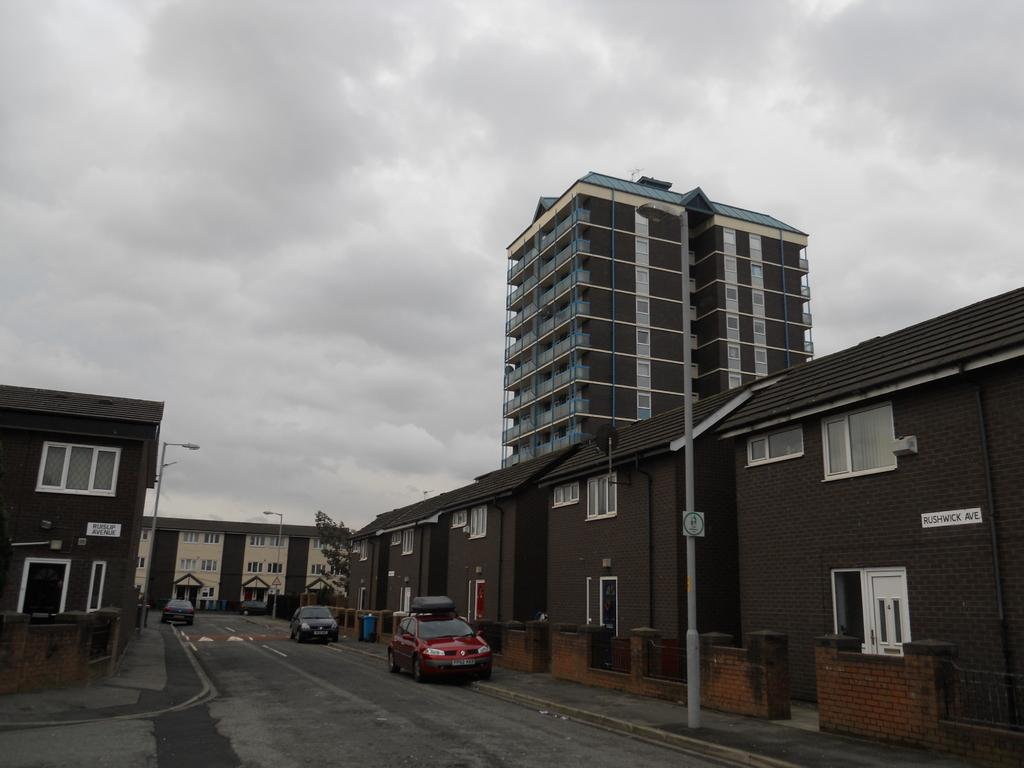What type of structures can be seen in the image? There are buildings in the image. What type of lighting is present in the image? There is a street lamp in the image. What type of vehicles are visible in the image? There are cars in the image. What type of plant life is present in the image? There is a tree in the image. What part of the natural environment is visible in the image? The sky is visible in the image, and clouds are present in the sky. What type of cushion is floating on the water in the image? There is no water or cushion present in the image; it features buildings, a street lamp, cars, a tree, and a sky with clouds. What type of nation is depicted in the image? The image does not depict a specific nation; it shows a general urban scene with buildings, cars, and a tree. 